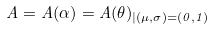<formula> <loc_0><loc_0><loc_500><loc_500>A = A ( \alpha ) = A ( \theta ) _ { | ( \mu , \sigma ) = ( 0 , 1 ) }</formula> 